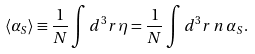<formula> <loc_0><loc_0><loc_500><loc_500>\langle \alpha _ { S } \rangle \equiv \frac { 1 } { N } \int d ^ { 3 } { r } \, \eta = \frac { 1 } { N } \int d ^ { 3 } { r } \, n \, \alpha _ { S } .</formula> 